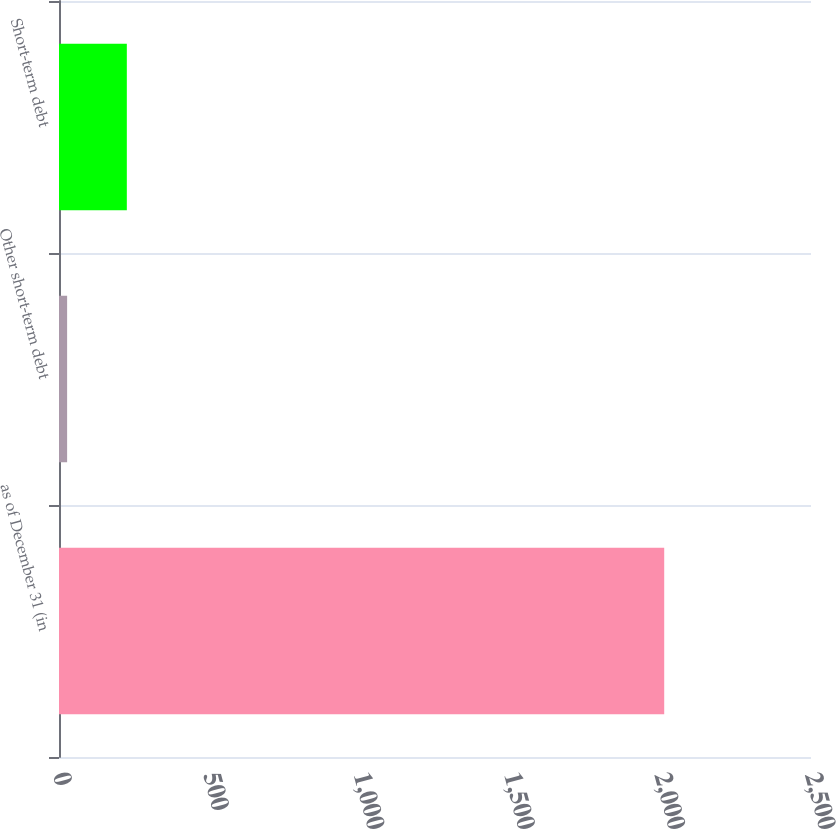Convert chart. <chart><loc_0><loc_0><loc_500><loc_500><bar_chart><fcel>as of December 31 (in<fcel>Other short-term debt<fcel>Short-term debt<nl><fcel>2012<fcel>27<fcel>225.5<nl></chart> 